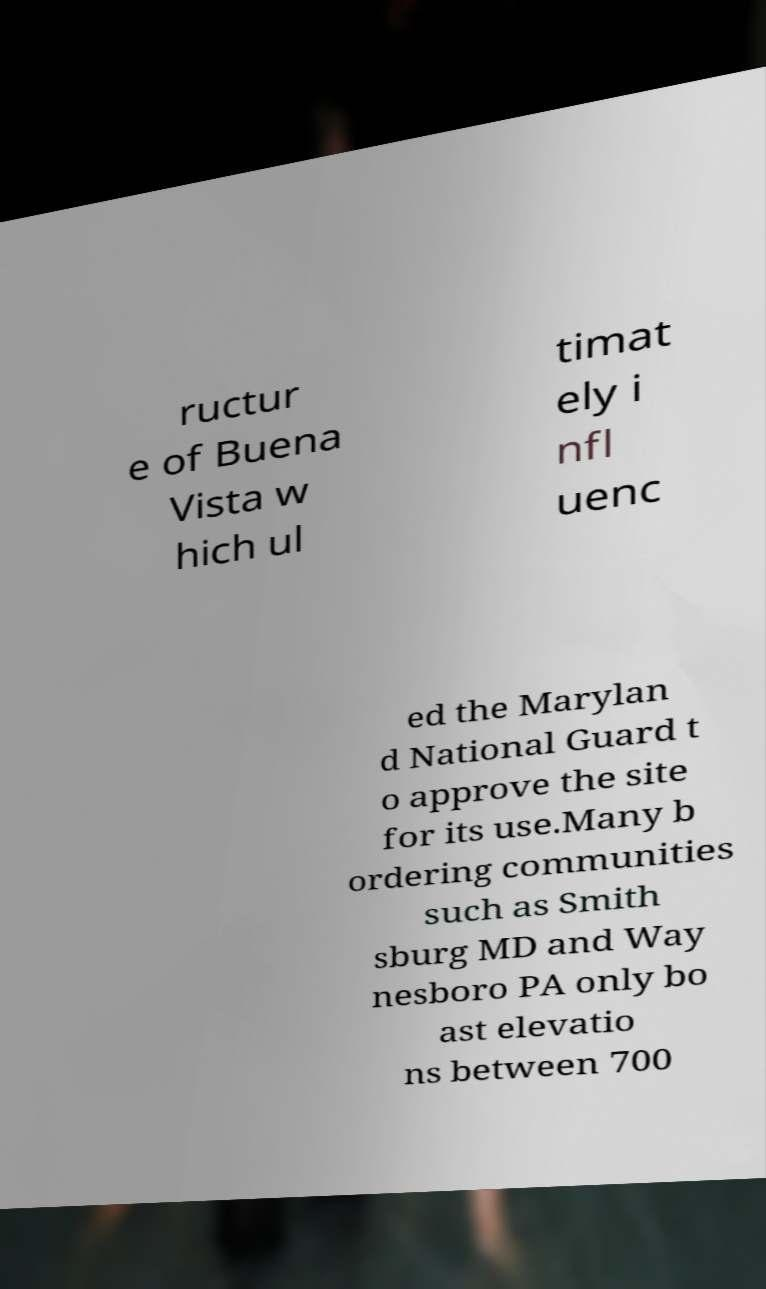Could you extract and type out the text from this image? ructur e of Buena Vista w hich ul timat ely i nfl uenc ed the Marylan d National Guard t o approve the site for its use.Many b ordering communities such as Smith sburg MD and Way nesboro PA only bo ast elevatio ns between 700 